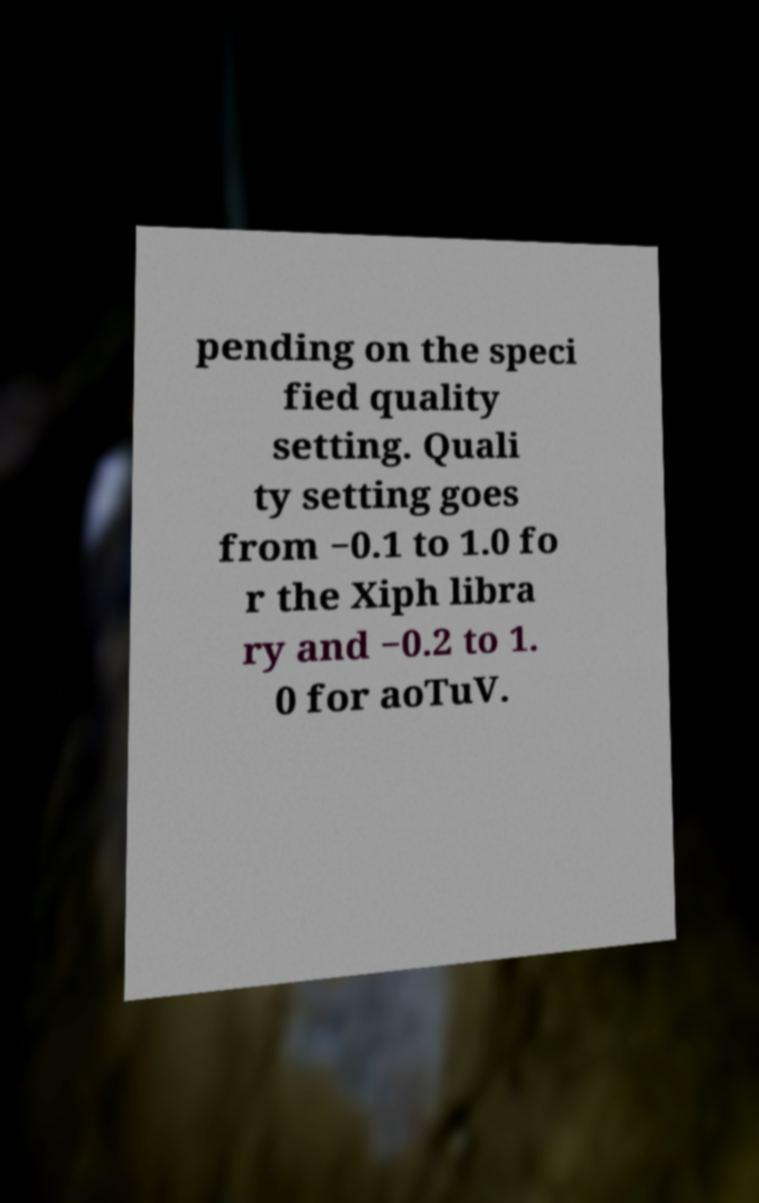There's text embedded in this image that I need extracted. Can you transcribe it verbatim? pending on the speci fied quality setting. Quali ty setting goes from −0.1 to 1.0 fo r the Xiph libra ry and −0.2 to 1. 0 for aoTuV. 